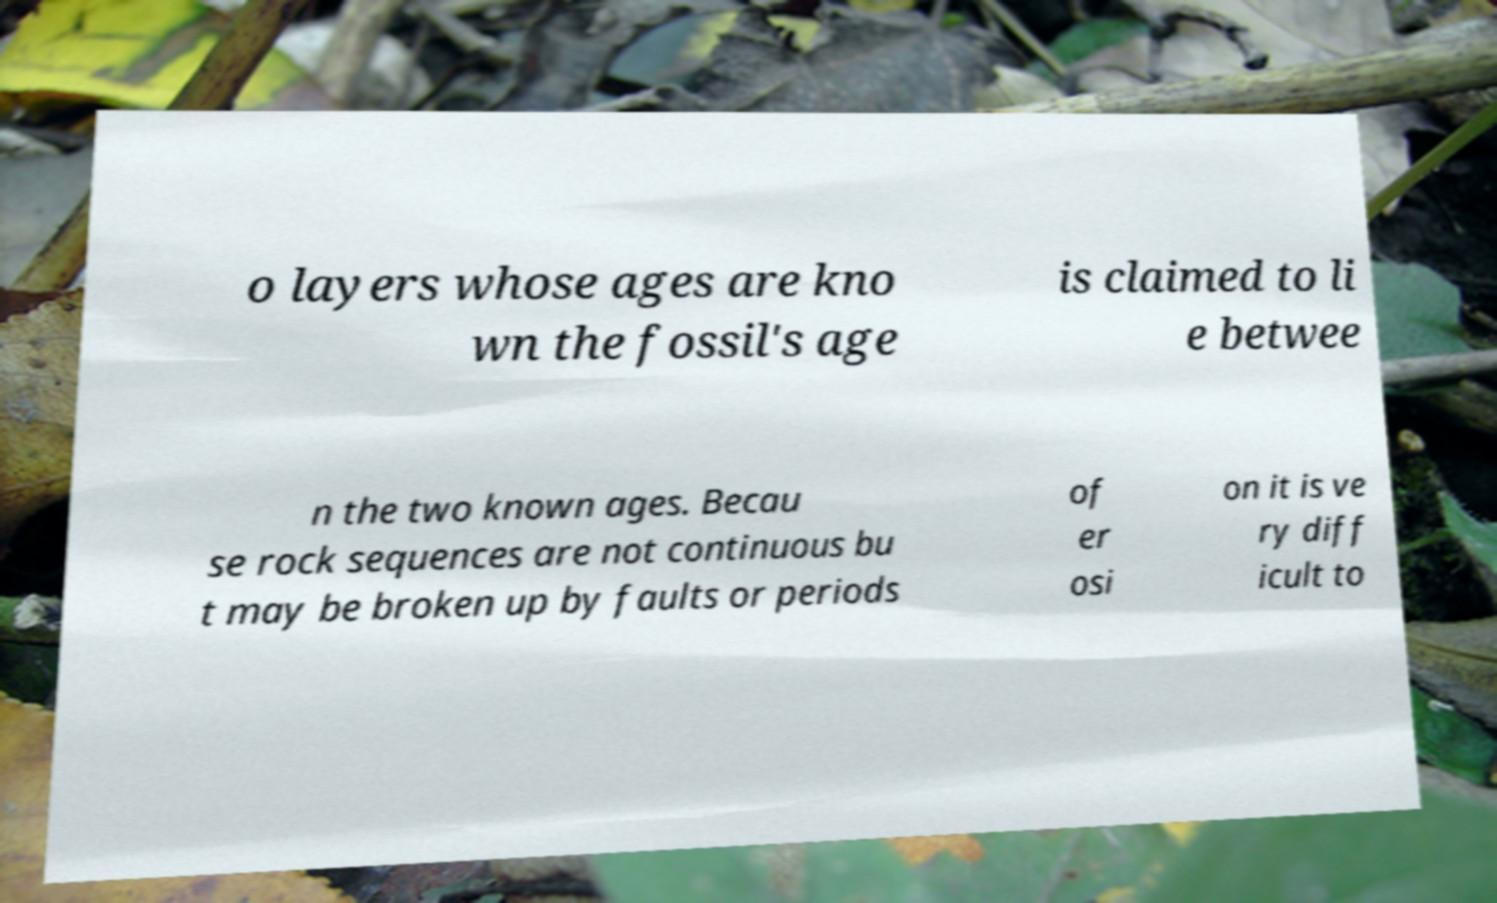Could you extract and type out the text from this image? o layers whose ages are kno wn the fossil's age is claimed to li e betwee n the two known ages. Becau se rock sequences are not continuous bu t may be broken up by faults or periods of er osi on it is ve ry diff icult to 